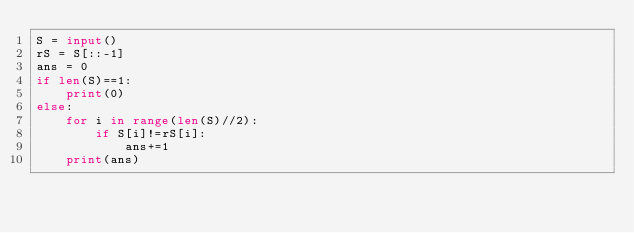<code> <loc_0><loc_0><loc_500><loc_500><_Python_>S = input()
rS = S[::-1]
ans = 0
if len(S)==1:
    print(0)
else:
    for i in range(len(S)//2):
        if S[i]!=rS[i]:
            ans+=1
    print(ans)</code> 